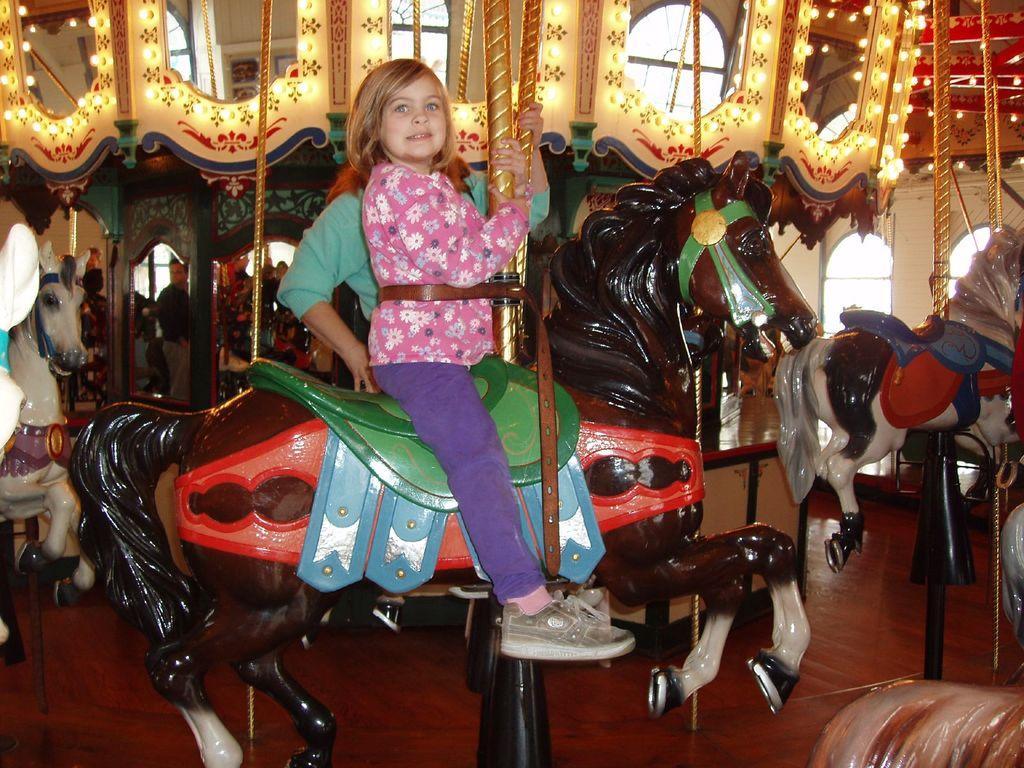How would you summarize this image in a sentence or two? This is the picture taken in a room, the girl in pink shirt was sitting on a toy horse. Behind the girl there is other person standing on the floor and group of people are also standing on the floor and the wall is decorated with lights. 